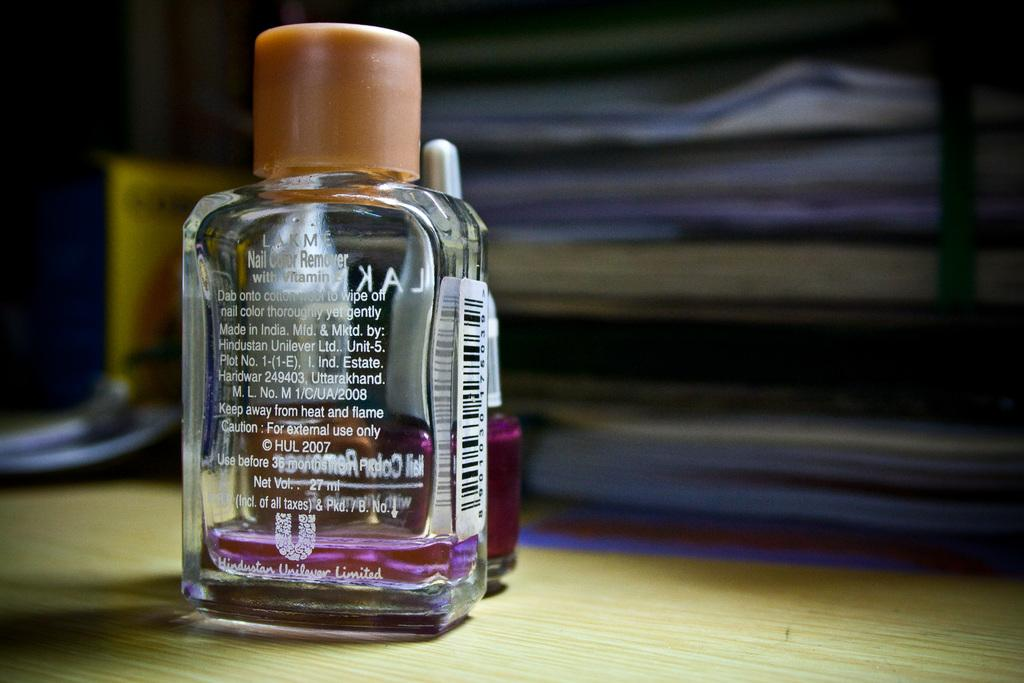<image>
Provide a brief description of the given image. A bottle of nail color remover was made by lakme. 